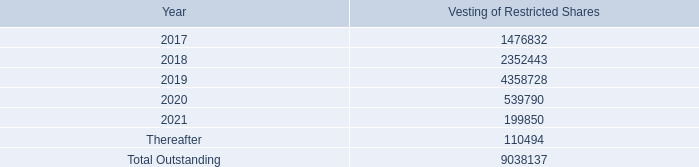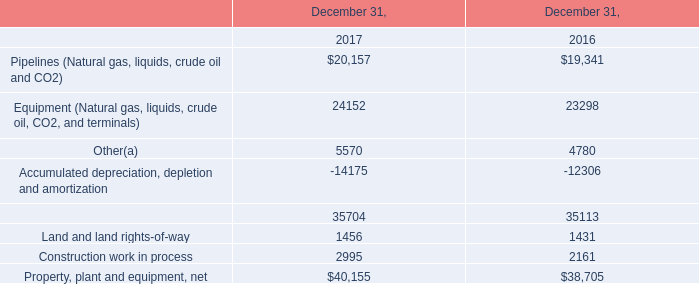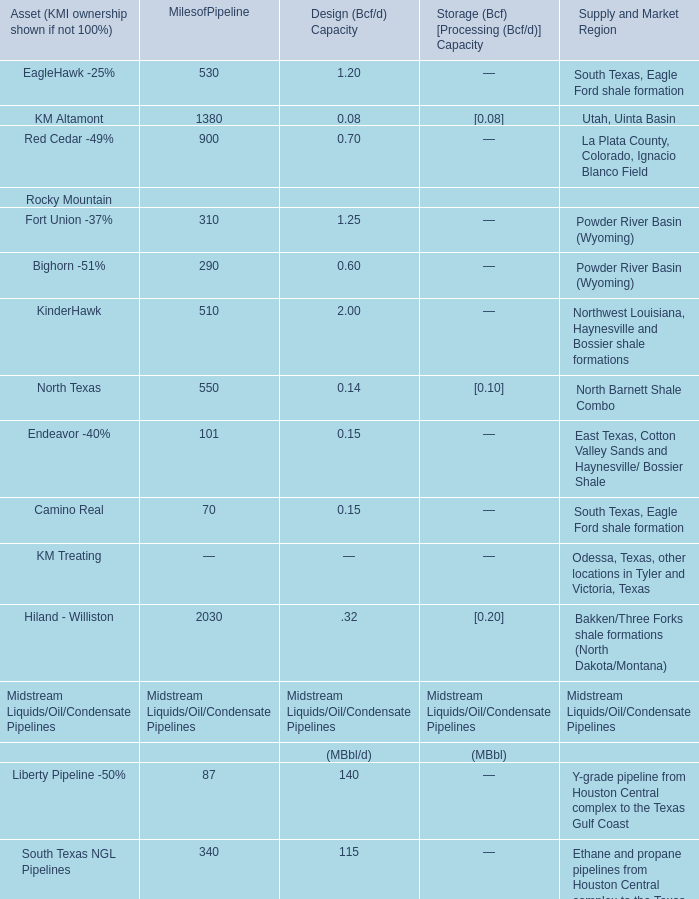What is the sum of the Camino Real of Rocky Mountain in the sections where Bighorn -51% is positive for Rocky Mountain? 
Computations: (70 + 0.15)
Answer: 70.15. 